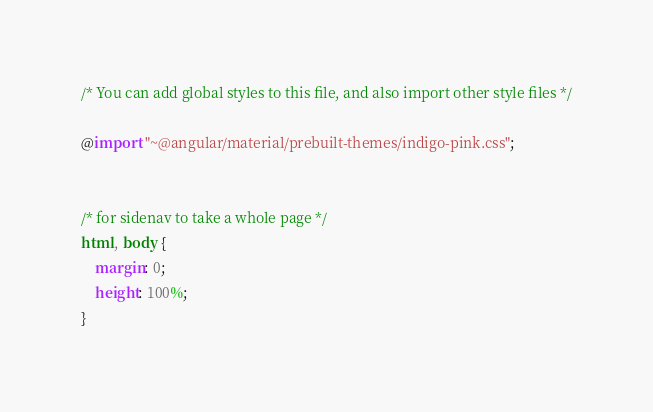<code> <loc_0><loc_0><loc_500><loc_500><_CSS_>/* You can add global styles to this file, and also import other style files */
	
@import "~@angular/material/prebuilt-themes/indigo-pink.css";


/* for sidenav to take a whole page */
html, body { 
    margin: 0;
    height: 100%;
}

</code> 